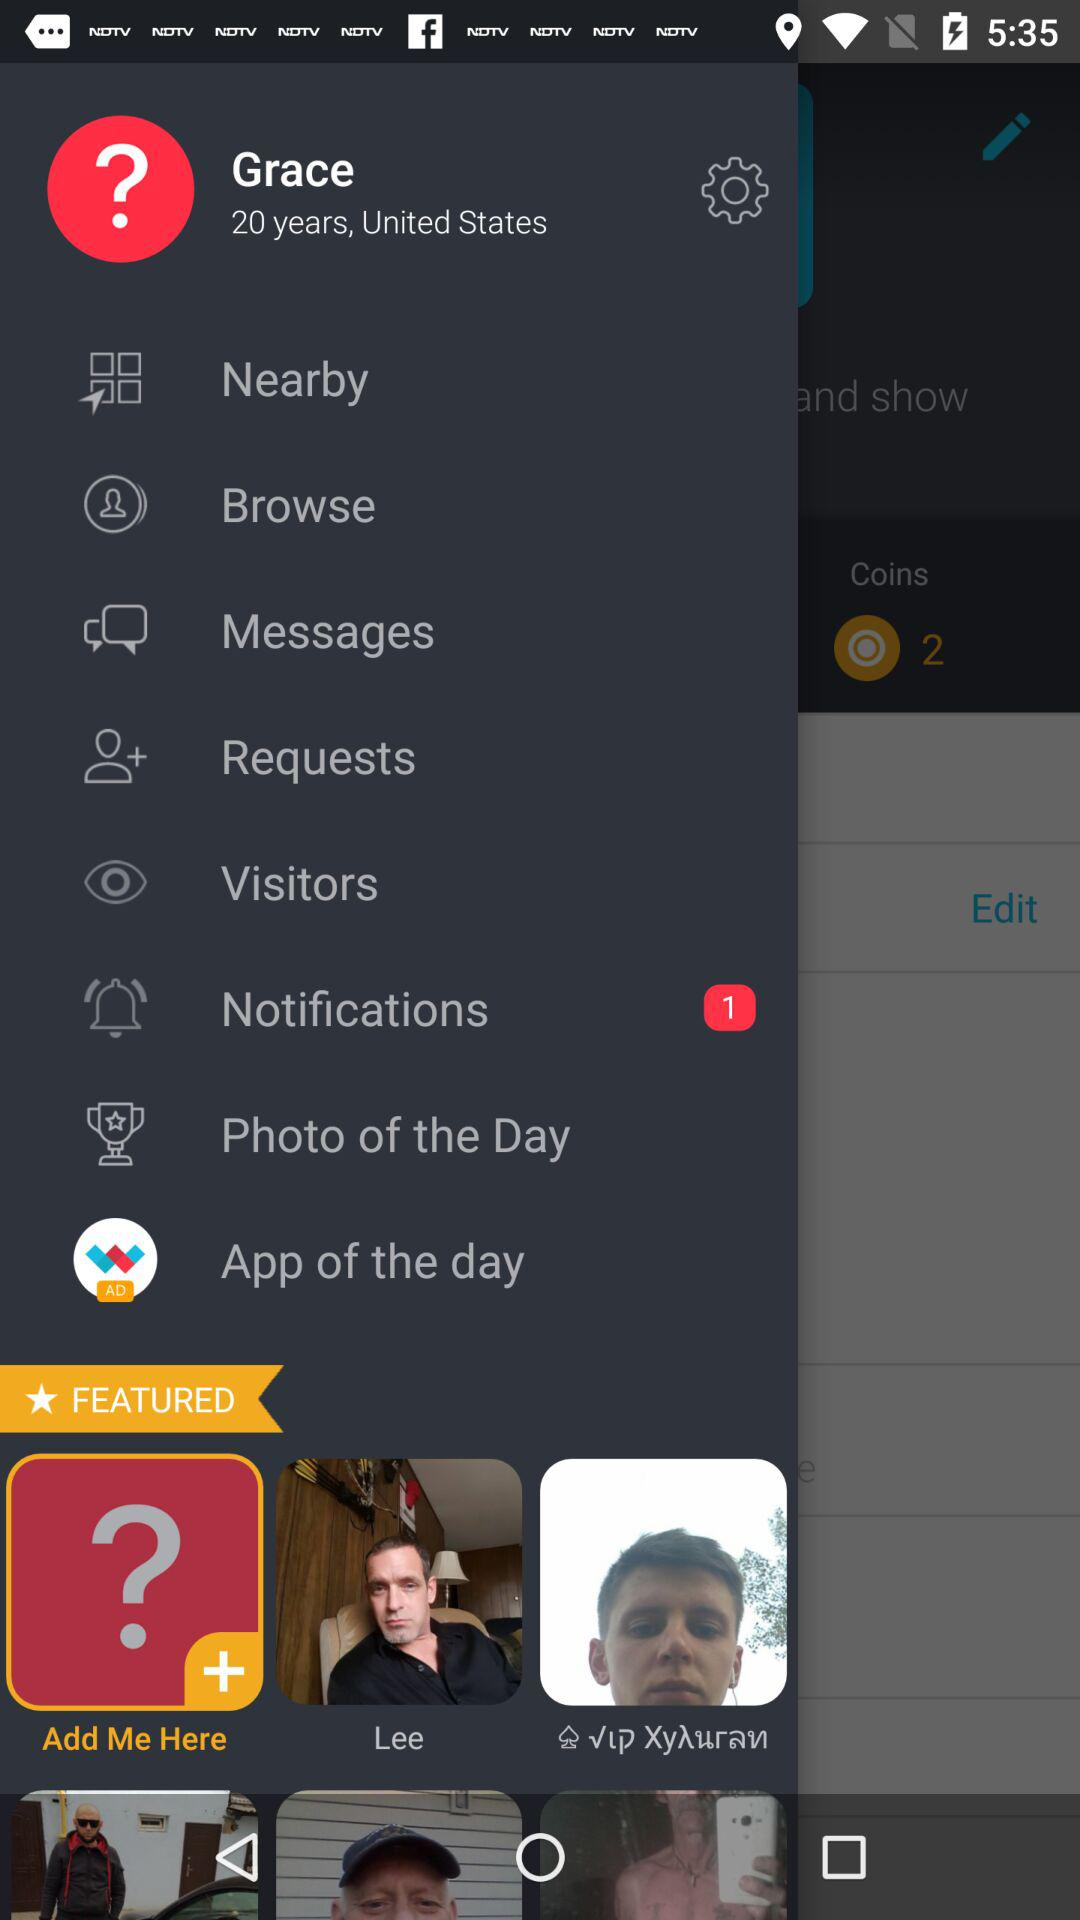What is the age of Grace? Grace is 20 years old. 